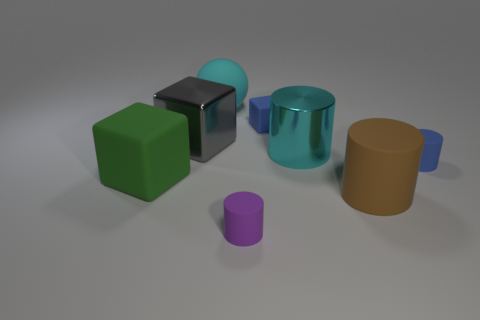There is a blue matte thing that is on the left side of the cyan cylinder; is its size the same as the purple matte thing?
Offer a terse response. Yes. What number of shiny things are gray cylinders or large balls?
Provide a succinct answer. 0. What number of gray cubes are to the right of the purple matte thing left of the large rubber cylinder?
Your response must be concise. 0. What shape is the object that is to the left of the tiny purple matte thing and in front of the small blue cylinder?
Your answer should be very brief. Cube. There is a large gray cube that is to the left of the large cyan thing that is to the right of the big thing behind the tiny cube; what is it made of?
Your answer should be compact. Metal. The object that is the same color as the small block is what size?
Offer a terse response. Small. What material is the gray object?
Offer a terse response. Metal. Does the purple cylinder have the same material as the thing right of the brown rubber cylinder?
Offer a terse response. Yes. The large metallic object to the right of the big gray block left of the ball is what color?
Make the answer very short. Cyan. How big is the object that is both in front of the gray cube and left of the cyan rubber ball?
Your answer should be very brief. Large. 